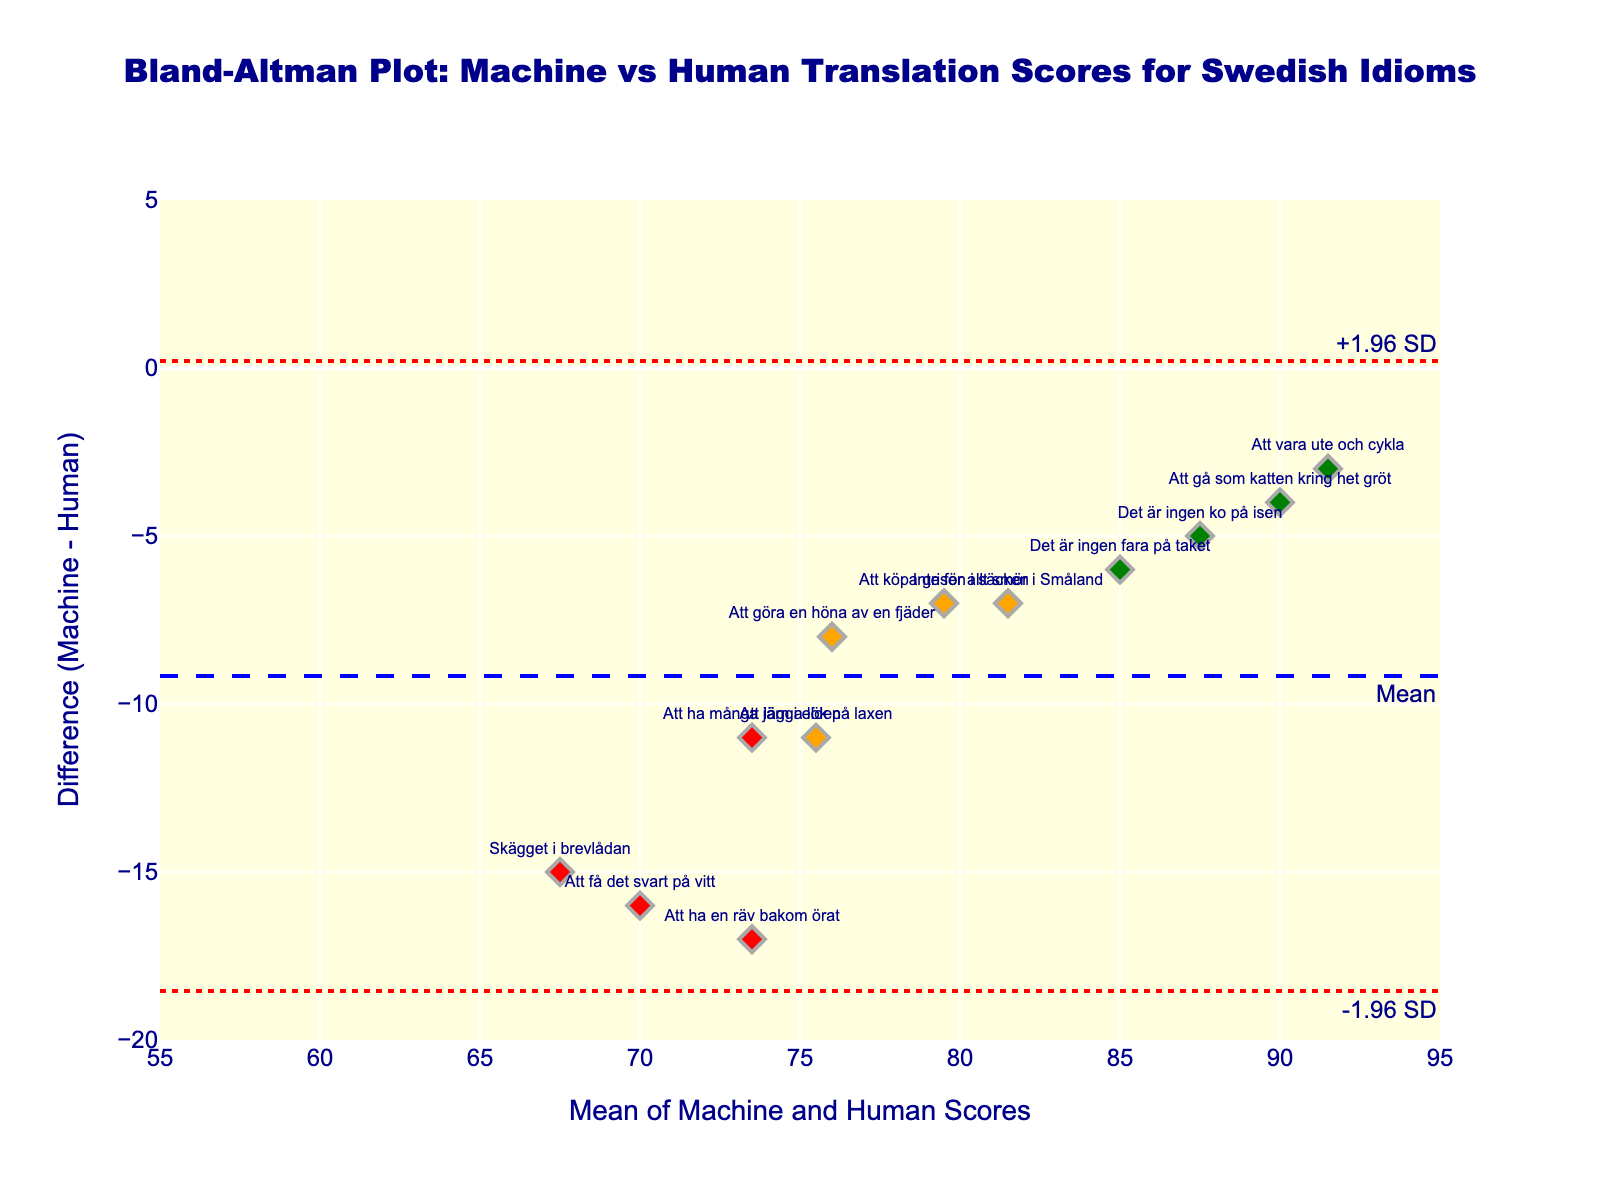What is the title of the plot? The title of the plot is located at the top-center of the figure and has a descriptive text about what is being visualized.
Answer: Bland-Altman Plot: Machine vs Human Translation Scores for Swedish Idioms What does the y-axis represent? By looking at the left side of the plot, we can see the y-axis label which indicates what data is plotted on this axis.
Answer: Difference (Machine - Human) How many idioms are represented in the plot? Each point on the plot corresponds to an idiom, with each having an associated label. We can count the total labels shown on the plot to determine the number of idioms.
Answer: 12 What color represents 'Hard' difficulty idioms? The color used for each difficulty category is shown by the color of the labels. By identifying the color used for 'Hard' categories in the plot, we can determine the representation.
Answer: Red What is the mean difference between machine and human scores? The horizontal line labeled "Mean" represents the mean difference between machine and human scores, indicated with a numerical annotation.
Answer: Approximately -5.58 Which idiom has the largest disagreement between machine and human scores? The largest difference can be identified by finding the point with the greatest vertical distance from the y-axis value of zero.
Answer: Skägget i brevlådan How are the limits of agreement represented in the plot? The limits of agreement are commonly represented by dotted lines which conform to the +1.96 and -1.96 standard deviations of the differences. We find these lines and the corresponding annotations.
Answer: Dotted lines at approximately -14.82 and 3.66 Do all idioms fall within the limits of agreement? To determine this, we look for any points that lie outside the dotted lines which represent the limits of agreement.
Answer: No How many idioms fall outside the limits of agreement? By counting the points that fall outside the area between the dotted lines, we can determine the exact number of idioms outside the limits.
Answer: 2 Which difficulty category shows the most consistent translation scores between machine and human translations? To evaluate consistency, we look at the scatter of points for each difficulty category and see which group has the tightest clustering around the mean difference.
Answer: Easy 